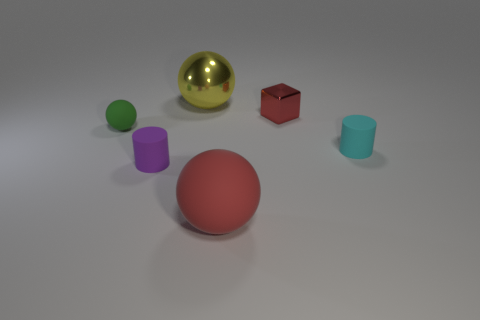What material is the tiny red block?
Your response must be concise. Metal. How many other things are the same shape as the large red thing?
Your answer should be very brief. 2. Is the tiny shiny thing the same shape as the cyan thing?
Make the answer very short. No. What number of objects are large balls that are behind the red matte sphere or spheres that are behind the small metallic cube?
Your response must be concise. 1. What number of things are tiny purple blocks or small cubes?
Ensure brevity in your answer.  1. How many tiny purple things are to the right of the matte thing that is on the right side of the tiny red thing?
Offer a terse response. 0. What number of other things are the same size as the red sphere?
Make the answer very short. 1. There is a thing that is the same color as the cube; what is its size?
Give a very brief answer. Large. Do the red object in front of the small green sphere and the small green matte object have the same shape?
Provide a succinct answer. Yes. What is the red thing behind the small cyan thing made of?
Provide a succinct answer. Metal. 